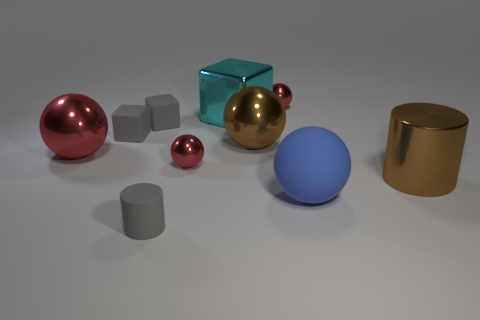Assuming these objects were real and not a render, what could be their practical applications? If these were real objects, the spheres and cylinder could serve as decorative ornaments or part of a sculpture due to their polished finishes. The cubes might serve more functional purposes like paperweights or building blocks if the material is sufficiently heavy and stable. 